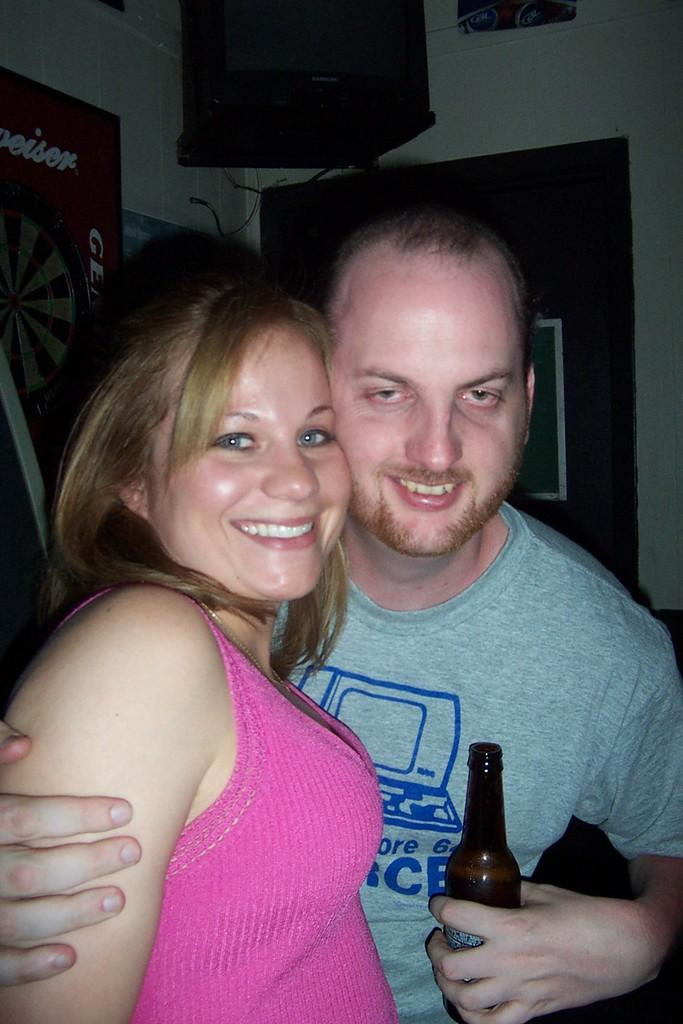How many people are in the image? There are two persons in the image. What are the people doing in the image? Both persons are standing and smiling. What is one person holding in the image? One person is holding a bottle. What can be seen in the background of the image? There is a wall in the background of the image, and there are posters on the wall. What type of butter is being used to create the artwork on the wall in the image? There is no butter or artwork visible on the wall in the image; it only features posters. How many rings are visible on the fingers of the persons in the image? There is no mention of rings on the fingers of the persons in the image. 